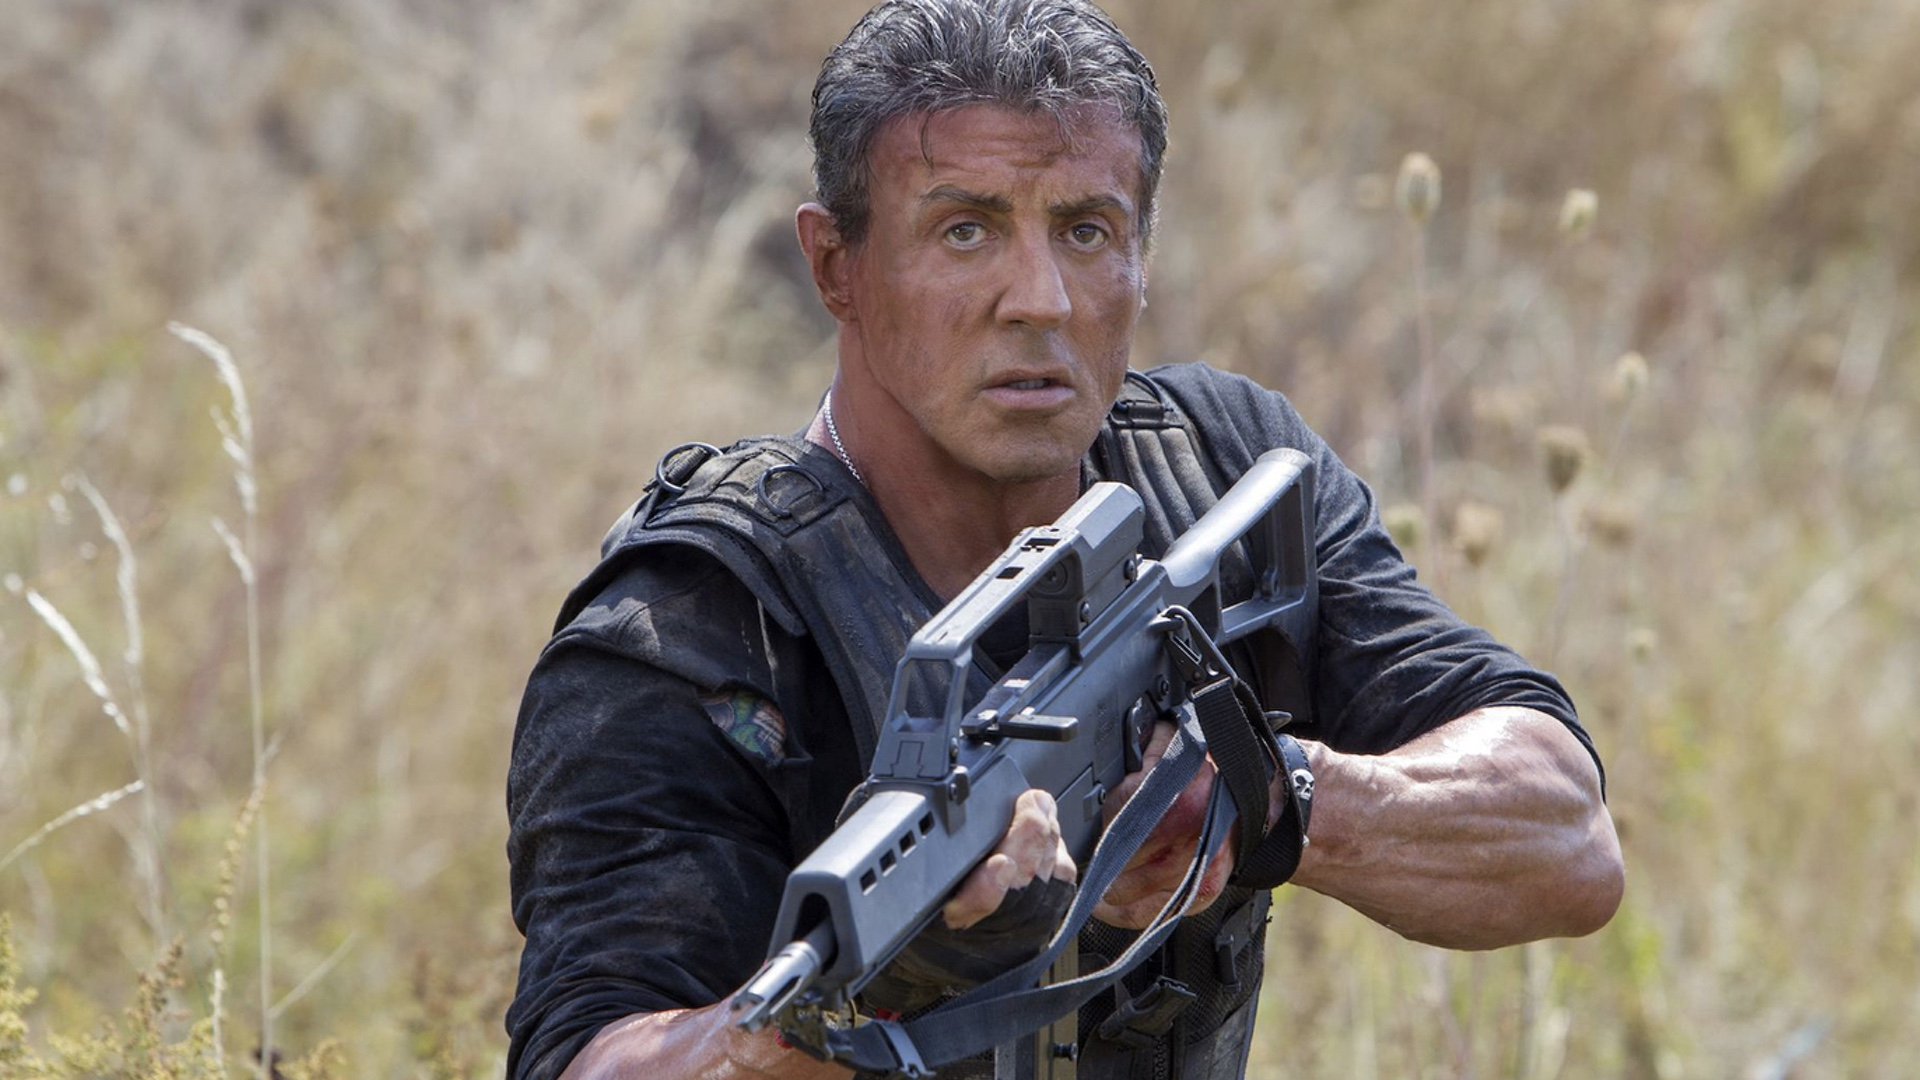Imagine Rambo encountered a mystical creature in the field. What might this interaction look like? As Rambo cautiously traverses the field, the tall grasses begin to sway rhythmically, as if an unseen force were carving a path toward him. Suddenly, emerging from the foliage, a mystical creature with luminescent scales and piercing blue eyes confronts him. Initially startled, Rambo instinctively raises his gun but hesitates, sensing no immediate threat from the enigmatic being. The creature, radiating a serene yet powerful aura, communicates telepathically with Rambo, revealing itself as a guardian of the forest. Their interaction signifies a rare moment of harmony as the creature imparts wisdom and guidance, leading Rambo to uncover a hidden truth about his mission and igniting a sense of purpose and connection with the natural world around him. 